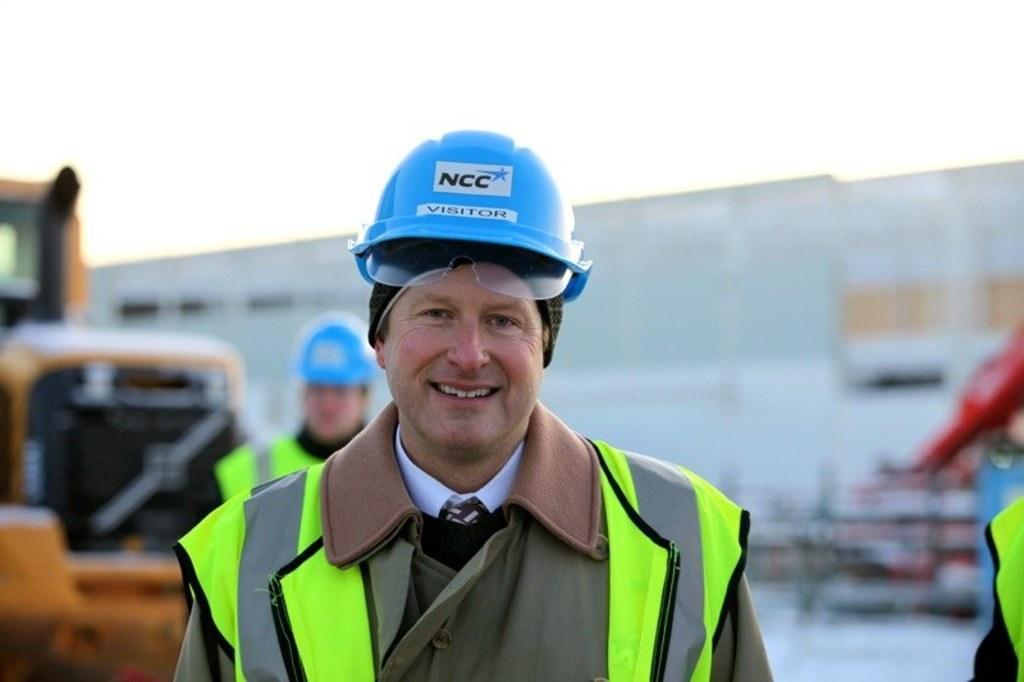How would you summarize this image in a sentence or two? This image consists of a man wearing a green jacket and a blue helmet. To the left, there is a vehicle. In the background, there is a wall. At the top, there is a sky. 